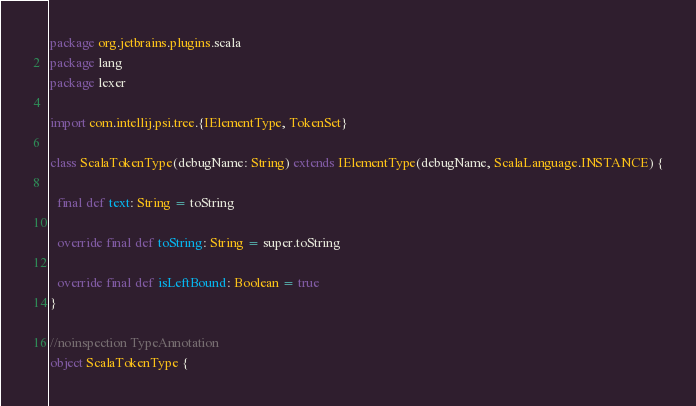<code> <loc_0><loc_0><loc_500><loc_500><_Scala_>package org.jetbrains.plugins.scala
package lang
package lexer

import com.intellij.psi.tree.{IElementType, TokenSet}

class ScalaTokenType(debugName: String) extends IElementType(debugName, ScalaLanguage.INSTANCE) {

  final def text: String = toString

  override final def toString: String = super.toString

  override final def isLeftBound: Boolean = true
}

//noinspection TypeAnnotation
object ScalaTokenType {
</code> 